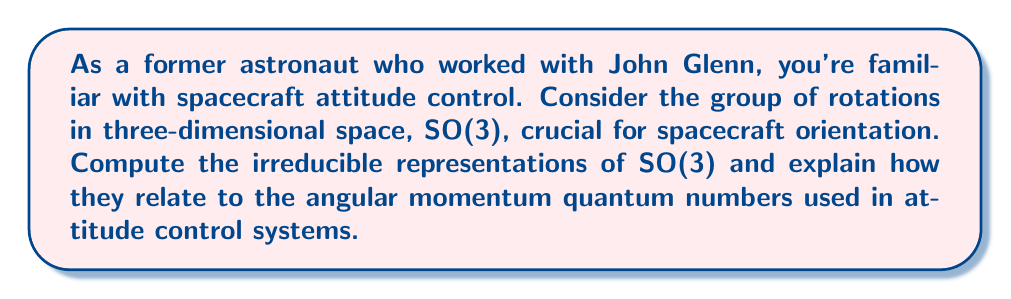Solve this math problem. To compute the irreducible representations of SO(3), we follow these steps:

1) Recall that SO(3) is a compact Lie group, and its irreducible representations are finite-dimensional.

2) The characters of irreducible representations of SO(3) are given by the Weyl character formula:

   $$\chi_l(\theta) = \frac{\sin((l+\frac{1}{2})\theta)}{\sin(\frac{\theta}{2})}$$

   where $l$ is a non-negative integer and $\theta$ is the angle of rotation.

3) Each irreducible representation $V_l$ has dimension $2l+1$.

4) The basis vectors of $V_l$ can be labeled by $m = -l, -l+1, ..., l-1, l$.

5) These representations correspond to the angular momentum states in quantum mechanics, where:
   - $l$ is the total angular momentum quantum number
   - $m$ is the magnetic quantum number

6) In the context of spacecraft attitude control:
   - $l=0$ corresponds to scalar quantities (no orientation dependence)
   - $l=1$ corresponds to vector quantities (e.g., angular velocity)
   - $l=2$ corresponds to tensor quantities (e.g., moment of inertia)

7) The action of a rotation $R(\alpha,\beta,\gamma)$ on a state $|l,m\rangle$ is given by the Wigner D-matrix:

   $$D^l_{m'm}(\alpha,\beta,\gamma) = \langle l,m'|R(\alpha,\beta,\gamma)|l,m\rangle$$

8) These D-matrices form the basis for describing rotations in attitude control systems, allowing for precise orientation calculations and adjustments.
Answer: The irreducible representations of SO(3) are $\{V_l : l = 0, 1, 2, ...\}$, where $V_l$ has dimension $2l+1$ and basis states $|l,m\rangle$ with $m = -l, ..., l$. 